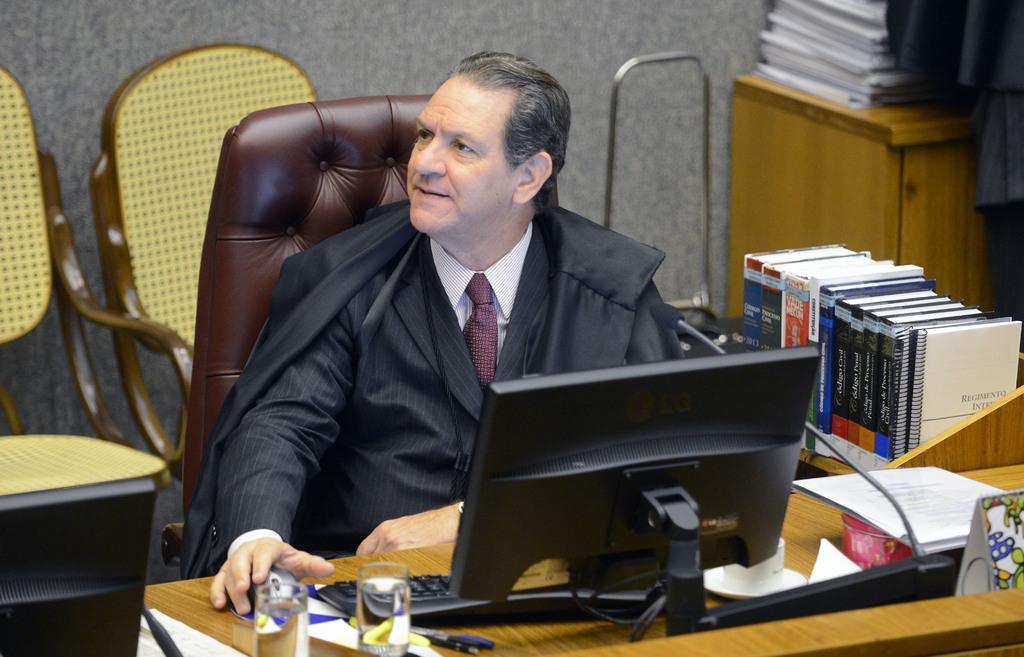Could you give a brief overview of what you see in this image? In this picture we can see man sitting on chair holding mouse with his hand and in front of him we can see table and on table we have glass, keyboard,monitor, paper beside to him we have books, cupboard and in background we can see wall, two chairs and here the person wore blazer, tie. 